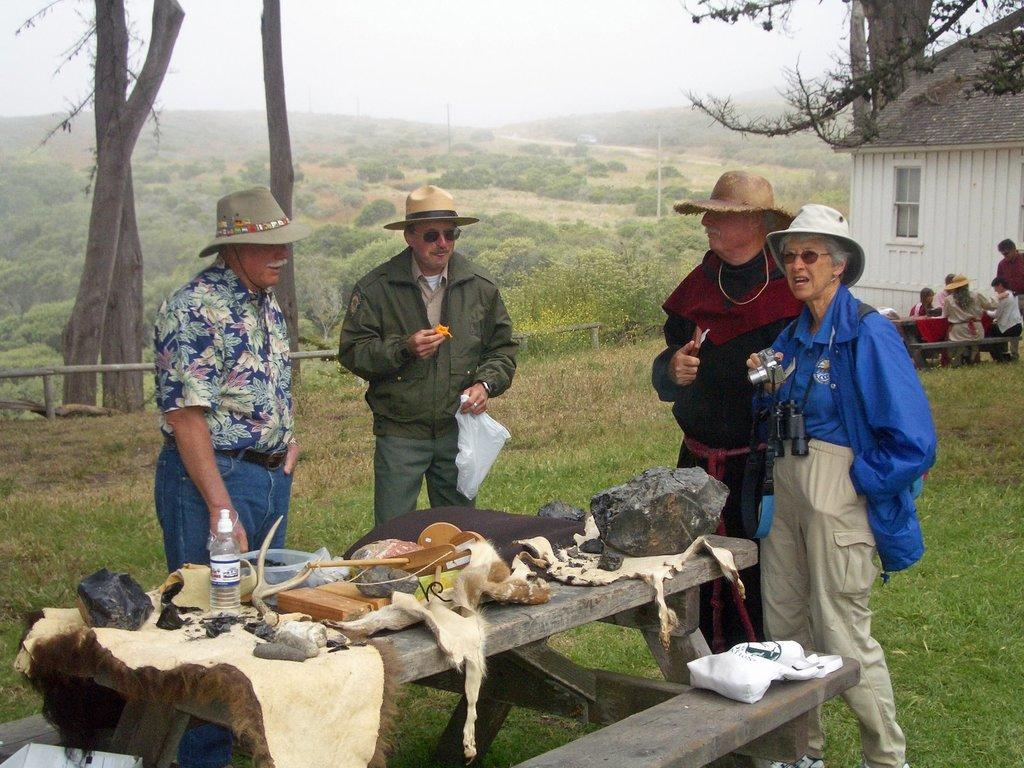What is the main subject of the image? There is a group of people on the ground. What is present in the image besides the group of people? There is a table, a bottle, and objects on the table in the image. What can be seen in the background of the image? There is a shed, trees, poles, and the sky visible in the background of the image. What type of shoes are the people wearing in the image? There is no information about shoes in the image, as it does not show the feet of the people. What is the taste of the objects on the table in the image? The taste of the objects on the table cannot be determined from the image. 